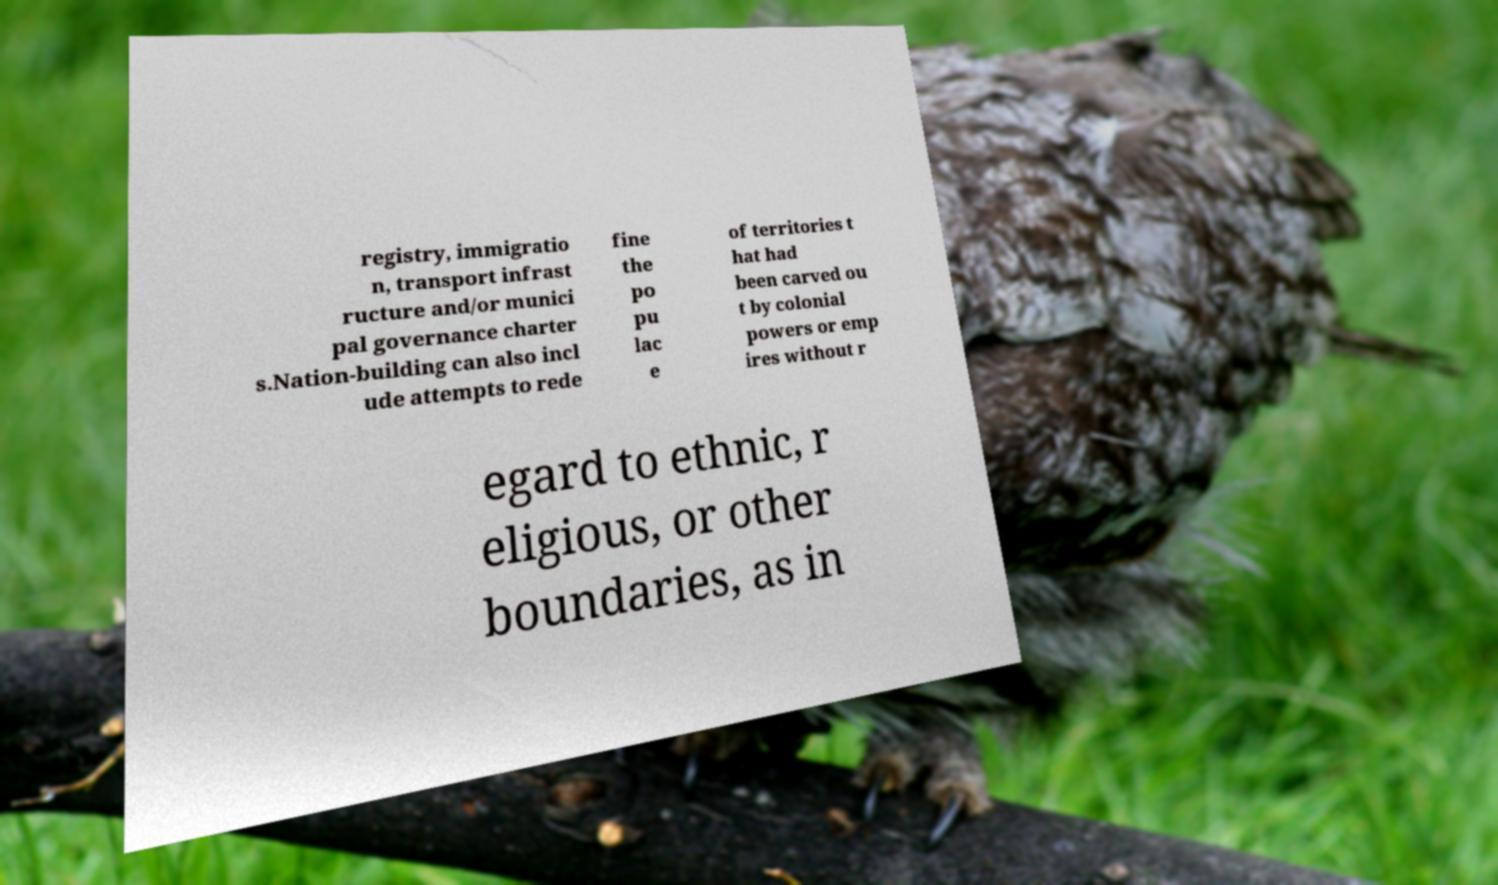What messages or text are displayed in this image? I need them in a readable, typed format. registry, immigratio n, transport infrast ructure and/or munici pal governance charter s.Nation-building can also incl ude attempts to rede fine the po pu lac e of territories t hat had been carved ou t by colonial powers or emp ires without r egard to ethnic, r eligious, or other boundaries, as in 